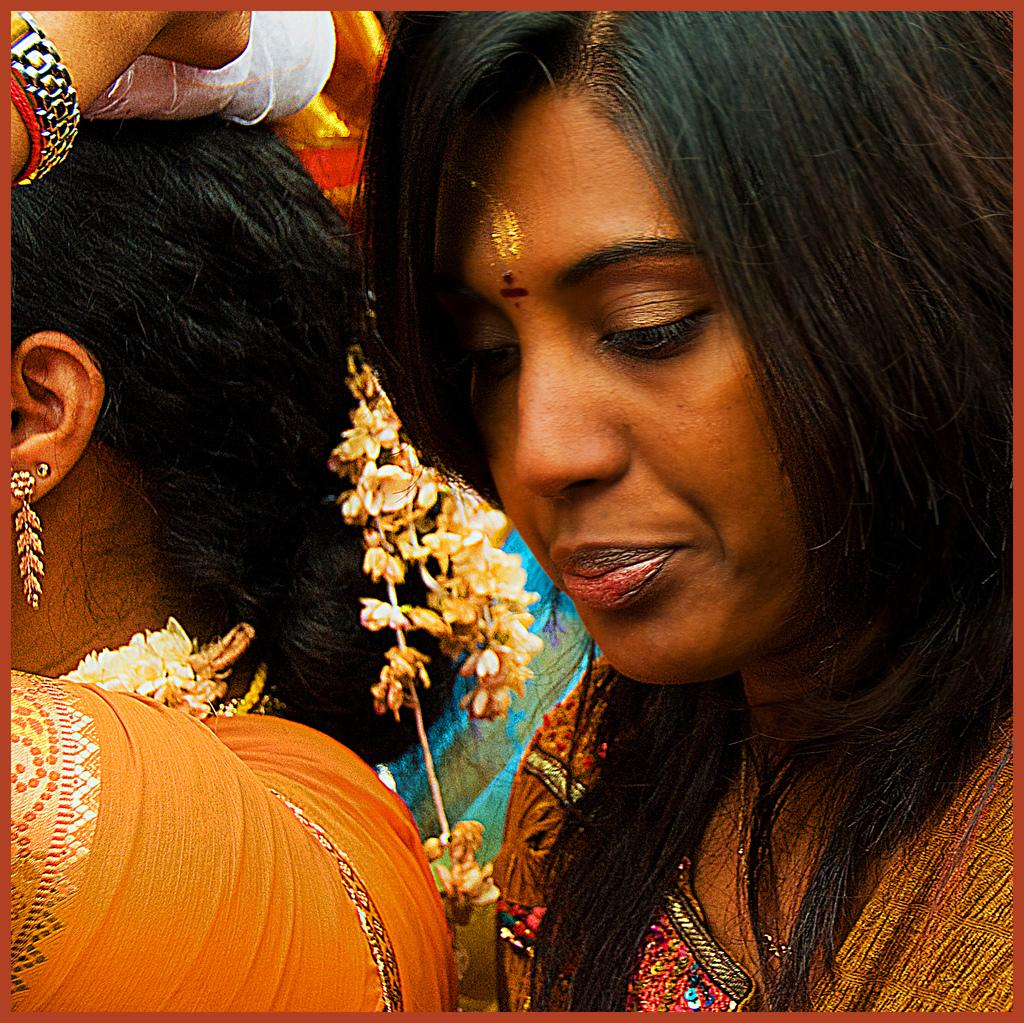How many people are in the image? There are two persons in the image. What are the persons wearing? Both persons are wearing clothes. What type of jeans is the celery wearing in the image? There is no celery or jeans present in the image. What color are the eyes of the person in the image? The provided facts do not mention the color of anyone's eyes in the image. 